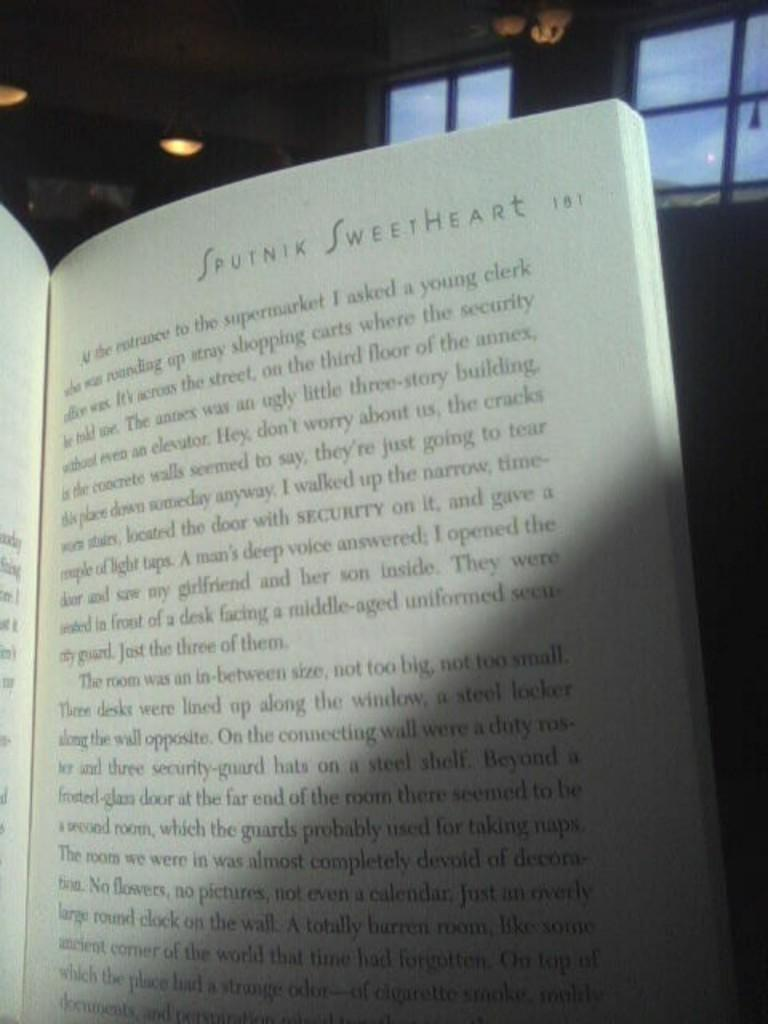<image>
Describe the image concisely. a book open to page 181 with the words 'sputnik sweetheart' at the top of it 